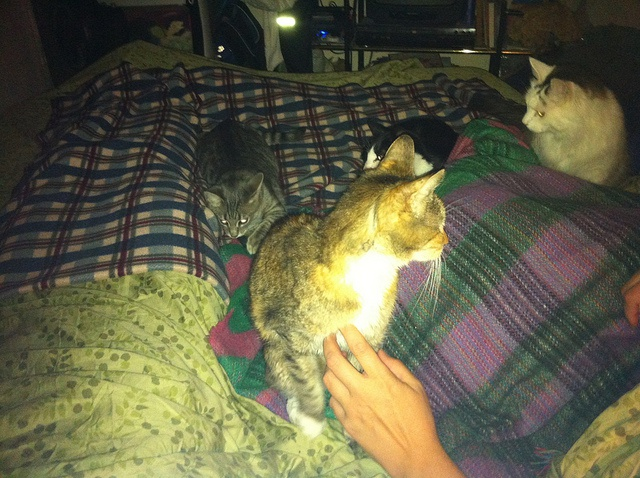Describe the objects in this image and their specific colors. I can see bed in black, gray, olive, and darkgreen tones, cat in black, olive, and khaki tones, people in black, tan, gold, khaki, and gray tones, cat in black and olive tones, and cat in black, gray, darkgreen, and olive tones in this image. 